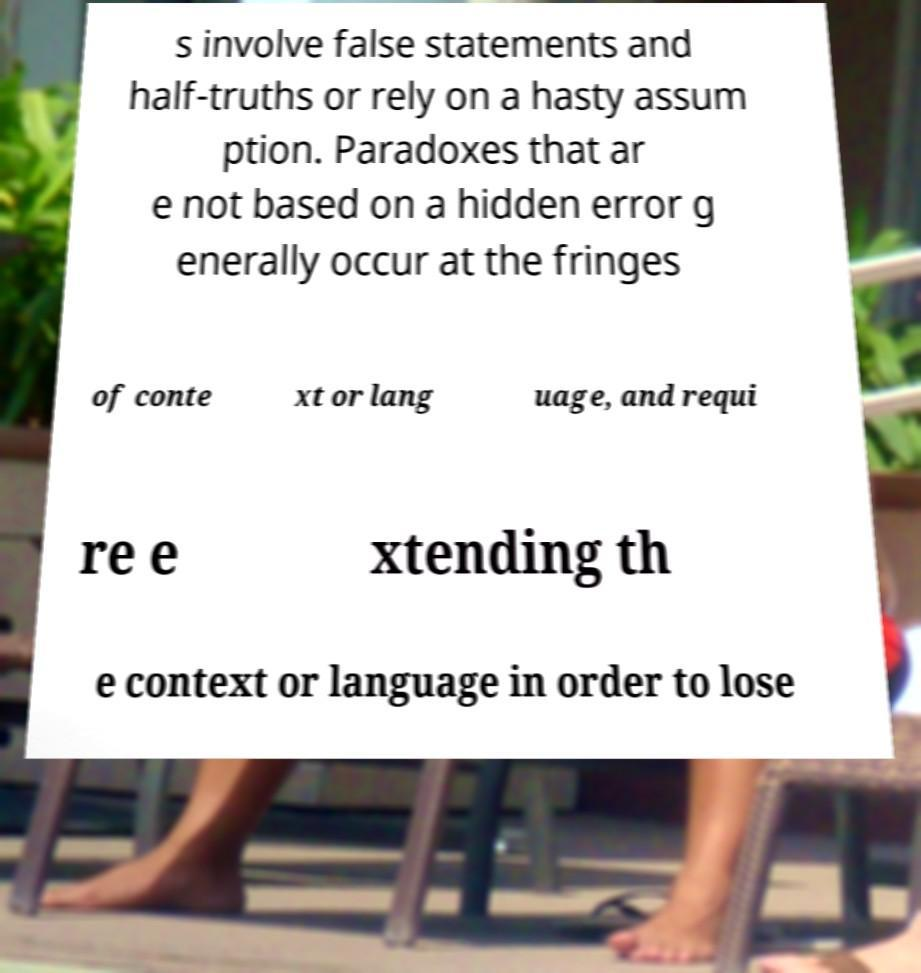Please identify and transcribe the text found in this image. s involve false statements and half-truths or rely on a hasty assum ption. Paradoxes that ar e not based on a hidden error g enerally occur at the fringes of conte xt or lang uage, and requi re e xtending th e context or language in order to lose 